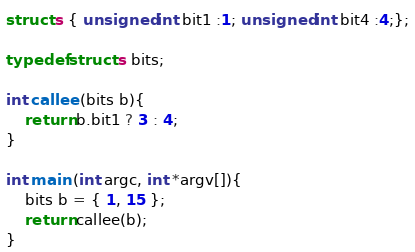<code> <loc_0><loc_0><loc_500><loc_500><_C_>struct s { unsigned int bit1 :1; unsigned int bit4 :4;};

typedef struct s bits;

int callee (bits b){
	return b.bit1 ? 3 : 4;
}

int main (int argc, int *argv[]){
	bits b = { 1, 15 };
	return callee(b);
}</code> 